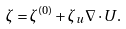Convert formula to latex. <formula><loc_0><loc_0><loc_500><loc_500>\zeta = \zeta ^ { ( 0 ) } + \zeta _ { u } \nabla \cdot { U } .</formula> 